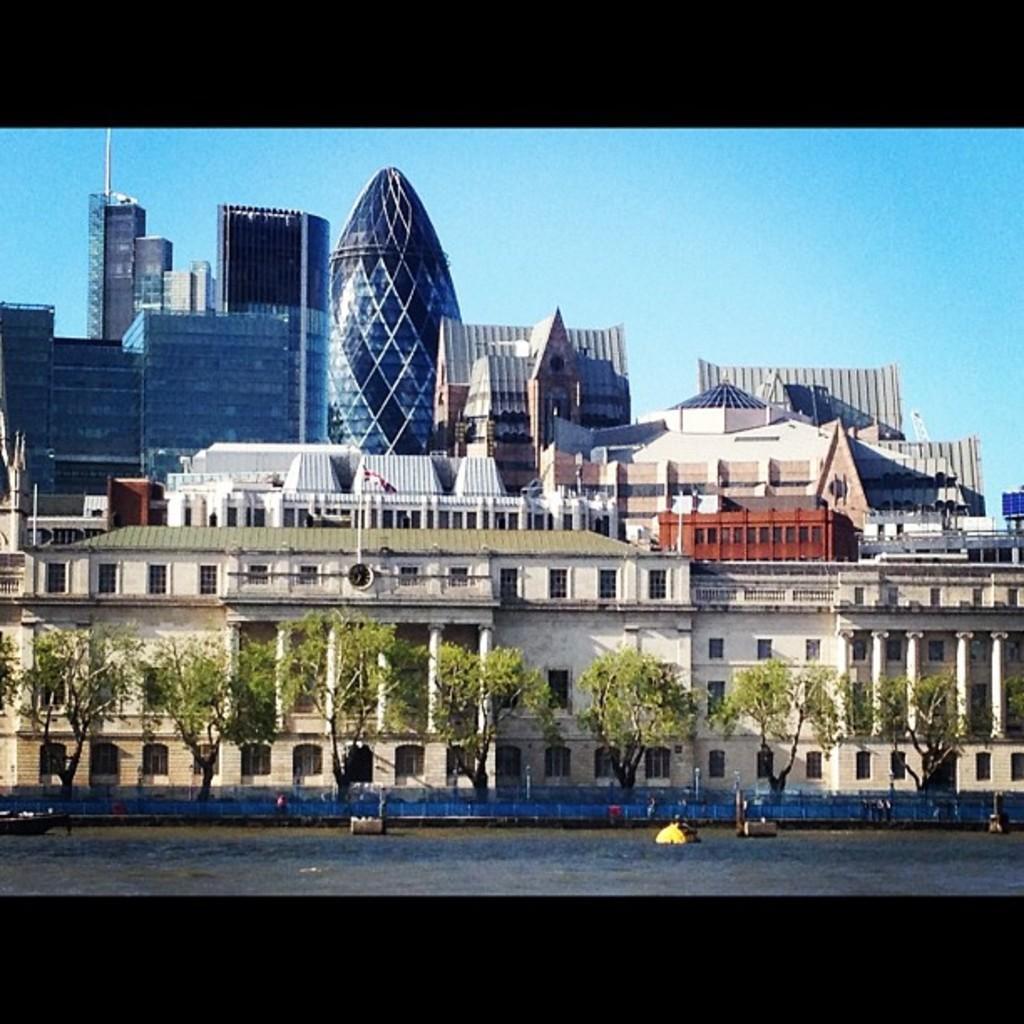How would you summarize this image in a sentence or two? In this image, we can see some trees in front of buildings. There are some objects floating on the water. There is a sky at the top of the image. 